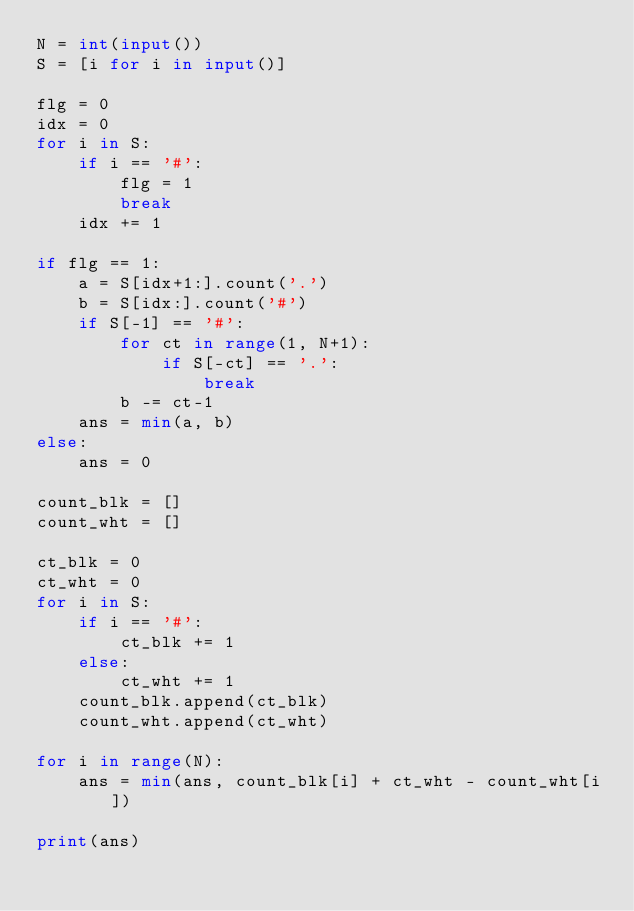Convert code to text. <code><loc_0><loc_0><loc_500><loc_500><_Python_>N = int(input())
S = [i for i in input()]

flg = 0
idx = 0
for i in S:
    if i == '#':
        flg = 1
        break
    idx += 1

if flg == 1:
    a = S[idx+1:].count('.')
    b = S[idx:].count('#')
    if S[-1] == '#':
        for ct in range(1, N+1):
            if S[-ct] == '.':
                break
        b -= ct-1
    ans = min(a, b)
else:
    ans = 0

count_blk = []
count_wht = []

ct_blk = 0
ct_wht = 0
for i in S:
    if i == '#':
        ct_blk += 1
    else:
        ct_wht += 1
    count_blk.append(ct_blk)
    count_wht.append(ct_wht)

for i in range(N):
    ans = min(ans, count_blk[i] + ct_wht - count_wht[i])

print(ans)
</code> 